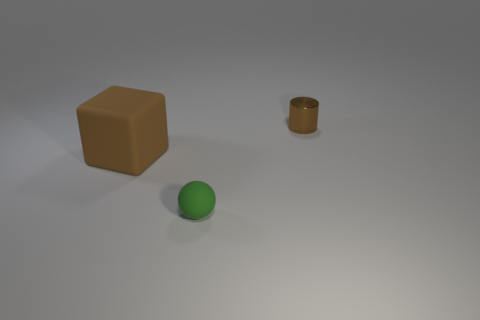Is there any other thing that is the same material as the cylinder?
Your answer should be very brief. No. What is the shape of the brown object that is on the right side of the large brown rubber object?
Provide a succinct answer. Cylinder. There is a small brown thing right of the matte object in front of the brown matte block; what shape is it?
Offer a very short reply. Cylinder. What shape is the object that is the same size as the ball?
Provide a short and direct response. Cylinder. Are there any tiny green rubber objects left of the small object that is left of the tiny object behind the tiny ball?
Offer a terse response. No. Is there a brown cylinder of the same size as the green object?
Your answer should be compact. Yes. How big is the brown thing that is to the left of the tiny matte thing?
Offer a very short reply. Large. There is a tiny object that is in front of the brown object that is behind the rubber thing that is on the left side of the tiny green matte thing; what is its color?
Give a very brief answer. Green. There is a object that is behind the brown thing that is in front of the tiny metal object; what is its color?
Keep it short and to the point. Brown. Are there more tiny matte objects that are in front of the ball than large brown cubes to the right of the big rubber cube?
Offer a terse response. No. 